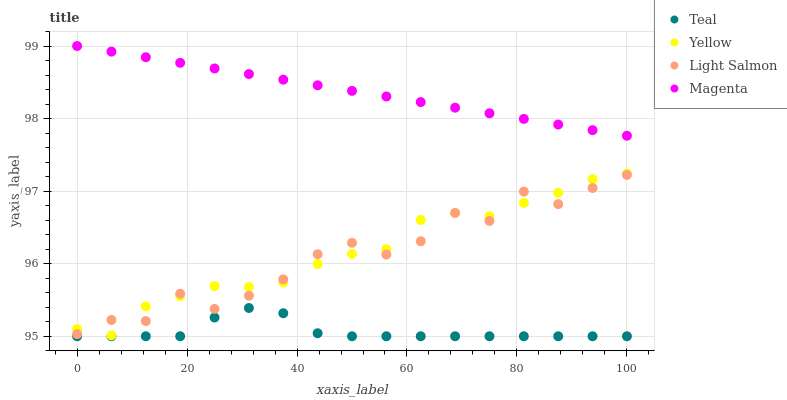Does Teal have the minimum area under the curve?
Answer yes or no. Yes. Does Magenta have the maximum area under the curve?
Answer yes or no. Yes. Does Yellow have the minimum area under the curve?
Answer yes or no. No. Does Yellow have the maximum area under the curve?
Answer yes or no. No. Is Magenta the smoothest?
Answer yes or no. Yes. Is Light Salmon the roughest?
Answer yes or no. Yes. Is Yellow the smoothest?
Answer yes or no. No. Is Yellow the roughest?
Answer yes or no. No. Does Teal have the lowest value?
Answer yes or no. Yes. Does Yellow have the lowest value?
Answer yes or no. No. Does Magenta have the highest value?
Answer yes or no. Yes. Does Yellow have the highest value?
Answer yes or no. No. Is Yellow less than Magenta?
Answer yes or no. Yes. Is Yellow greater than Teal?
Answer yes or no. Yes. Does Yellow intersect Light Salmon?
Answer yes or no. Yes. Is Yellow less than Light Salmon?
Answer yes or no. No. Is Yellow greater than Light Salmon?
Answer yes or no. No. Does Yellow intersect Magenta?
Answer yes or no. No. 